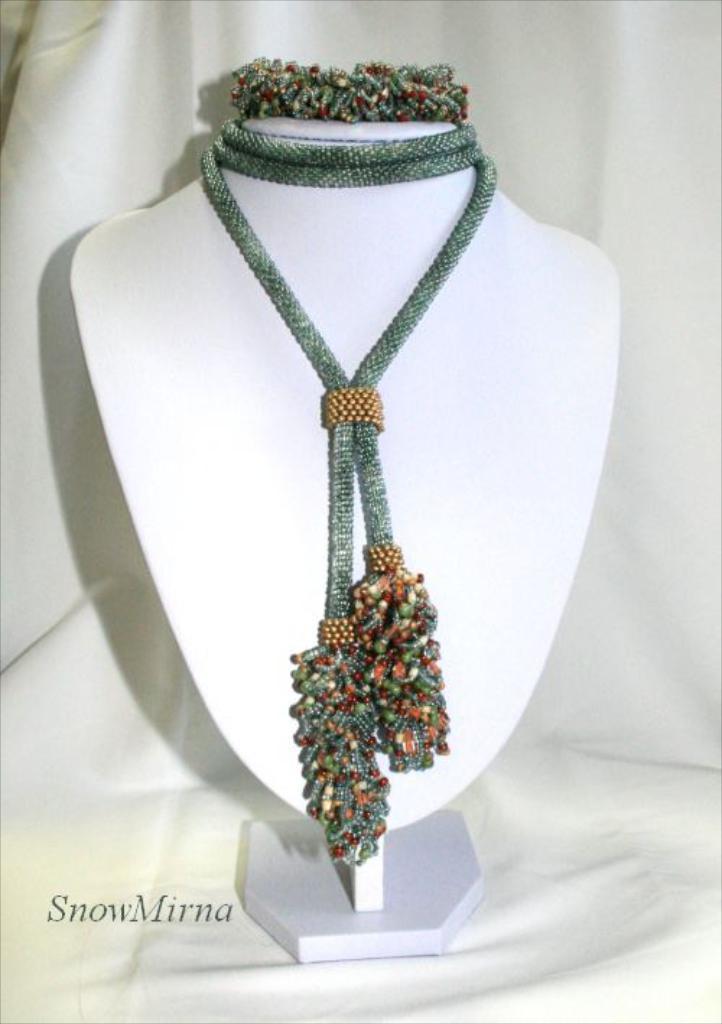Please provide a concise description of this image. It's a jewelry ornament. 